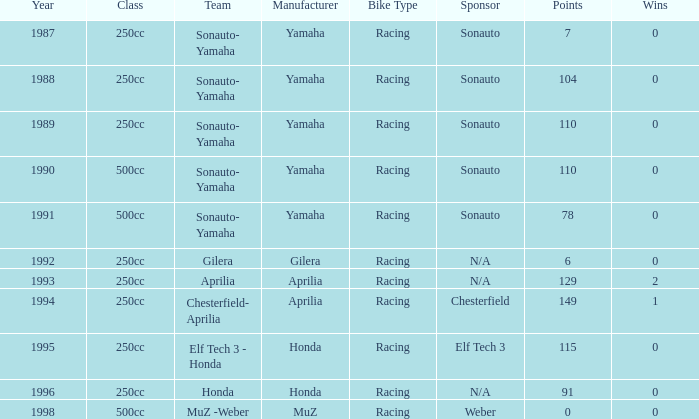What is the highest number of points the team with 0 wins had before 1992? 110.0. 